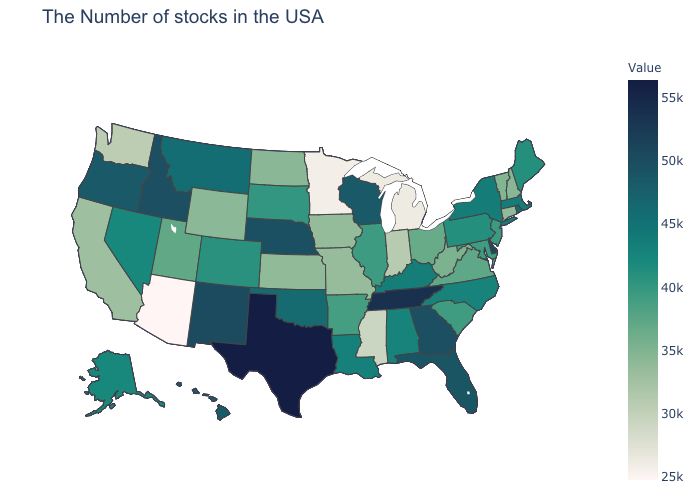Among the states that border Texas , which have the lowest value?
Keep it brief. Arkansas. Does the map have missing data?
Write a very short answer. No. 